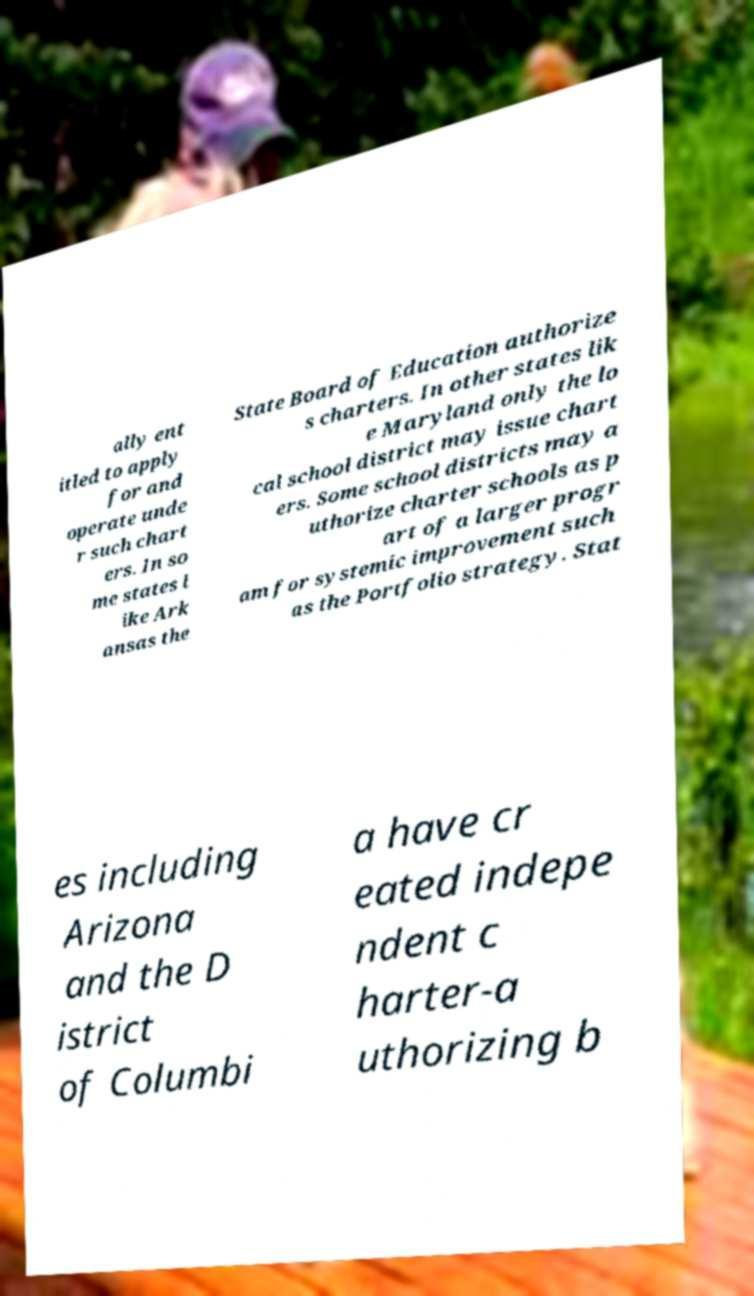Can you read and provide the text displayed in the image?This photo seems to have some interesting text. Can you extract and type it out for me? ally ent itled to apply for and operate unde r such chart ers. In so me states l ike Ark ansas the State Board of Education authorize s charters. In other states lik e Maryland only the lo cal school district may issue chart ers. Some school districts may a uthorize charter schools as p art of a larger progr am for systemic improvement such as the Portfolio strategy. Stat es including Arizona and the D istrict of Columbi a have cr eated indepe ndent c harter-a uthorizing b 